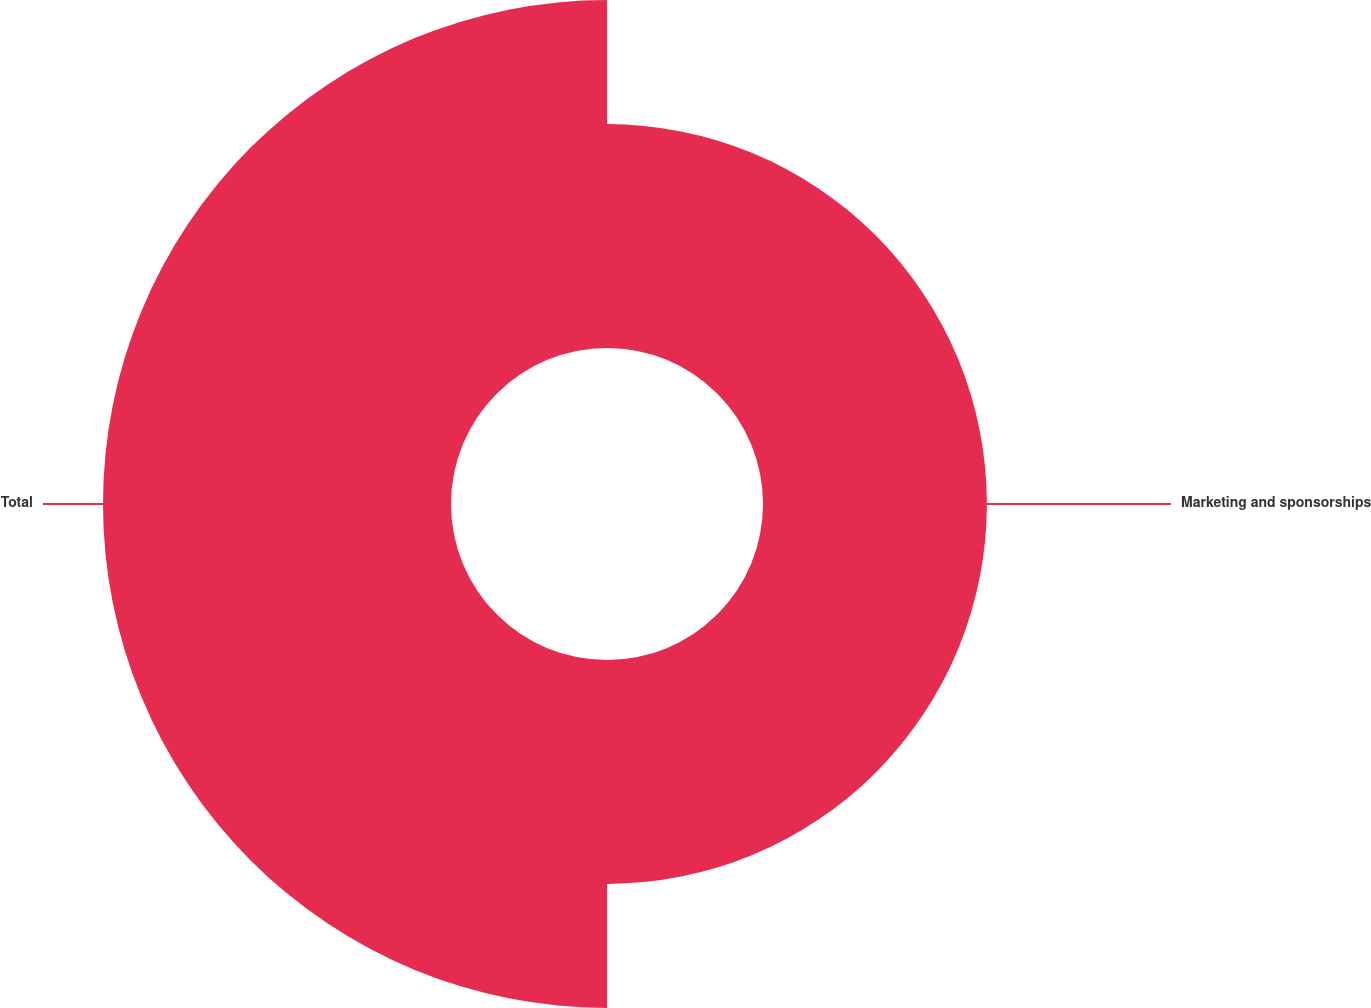<chart> <loc_0><loc_0><loc_500><loc_500><pie_chart><fcel>Marketing and sponsorships<fcel>Total<nl><fcel>39.15%<fcel>60.85%<nl></chart> 